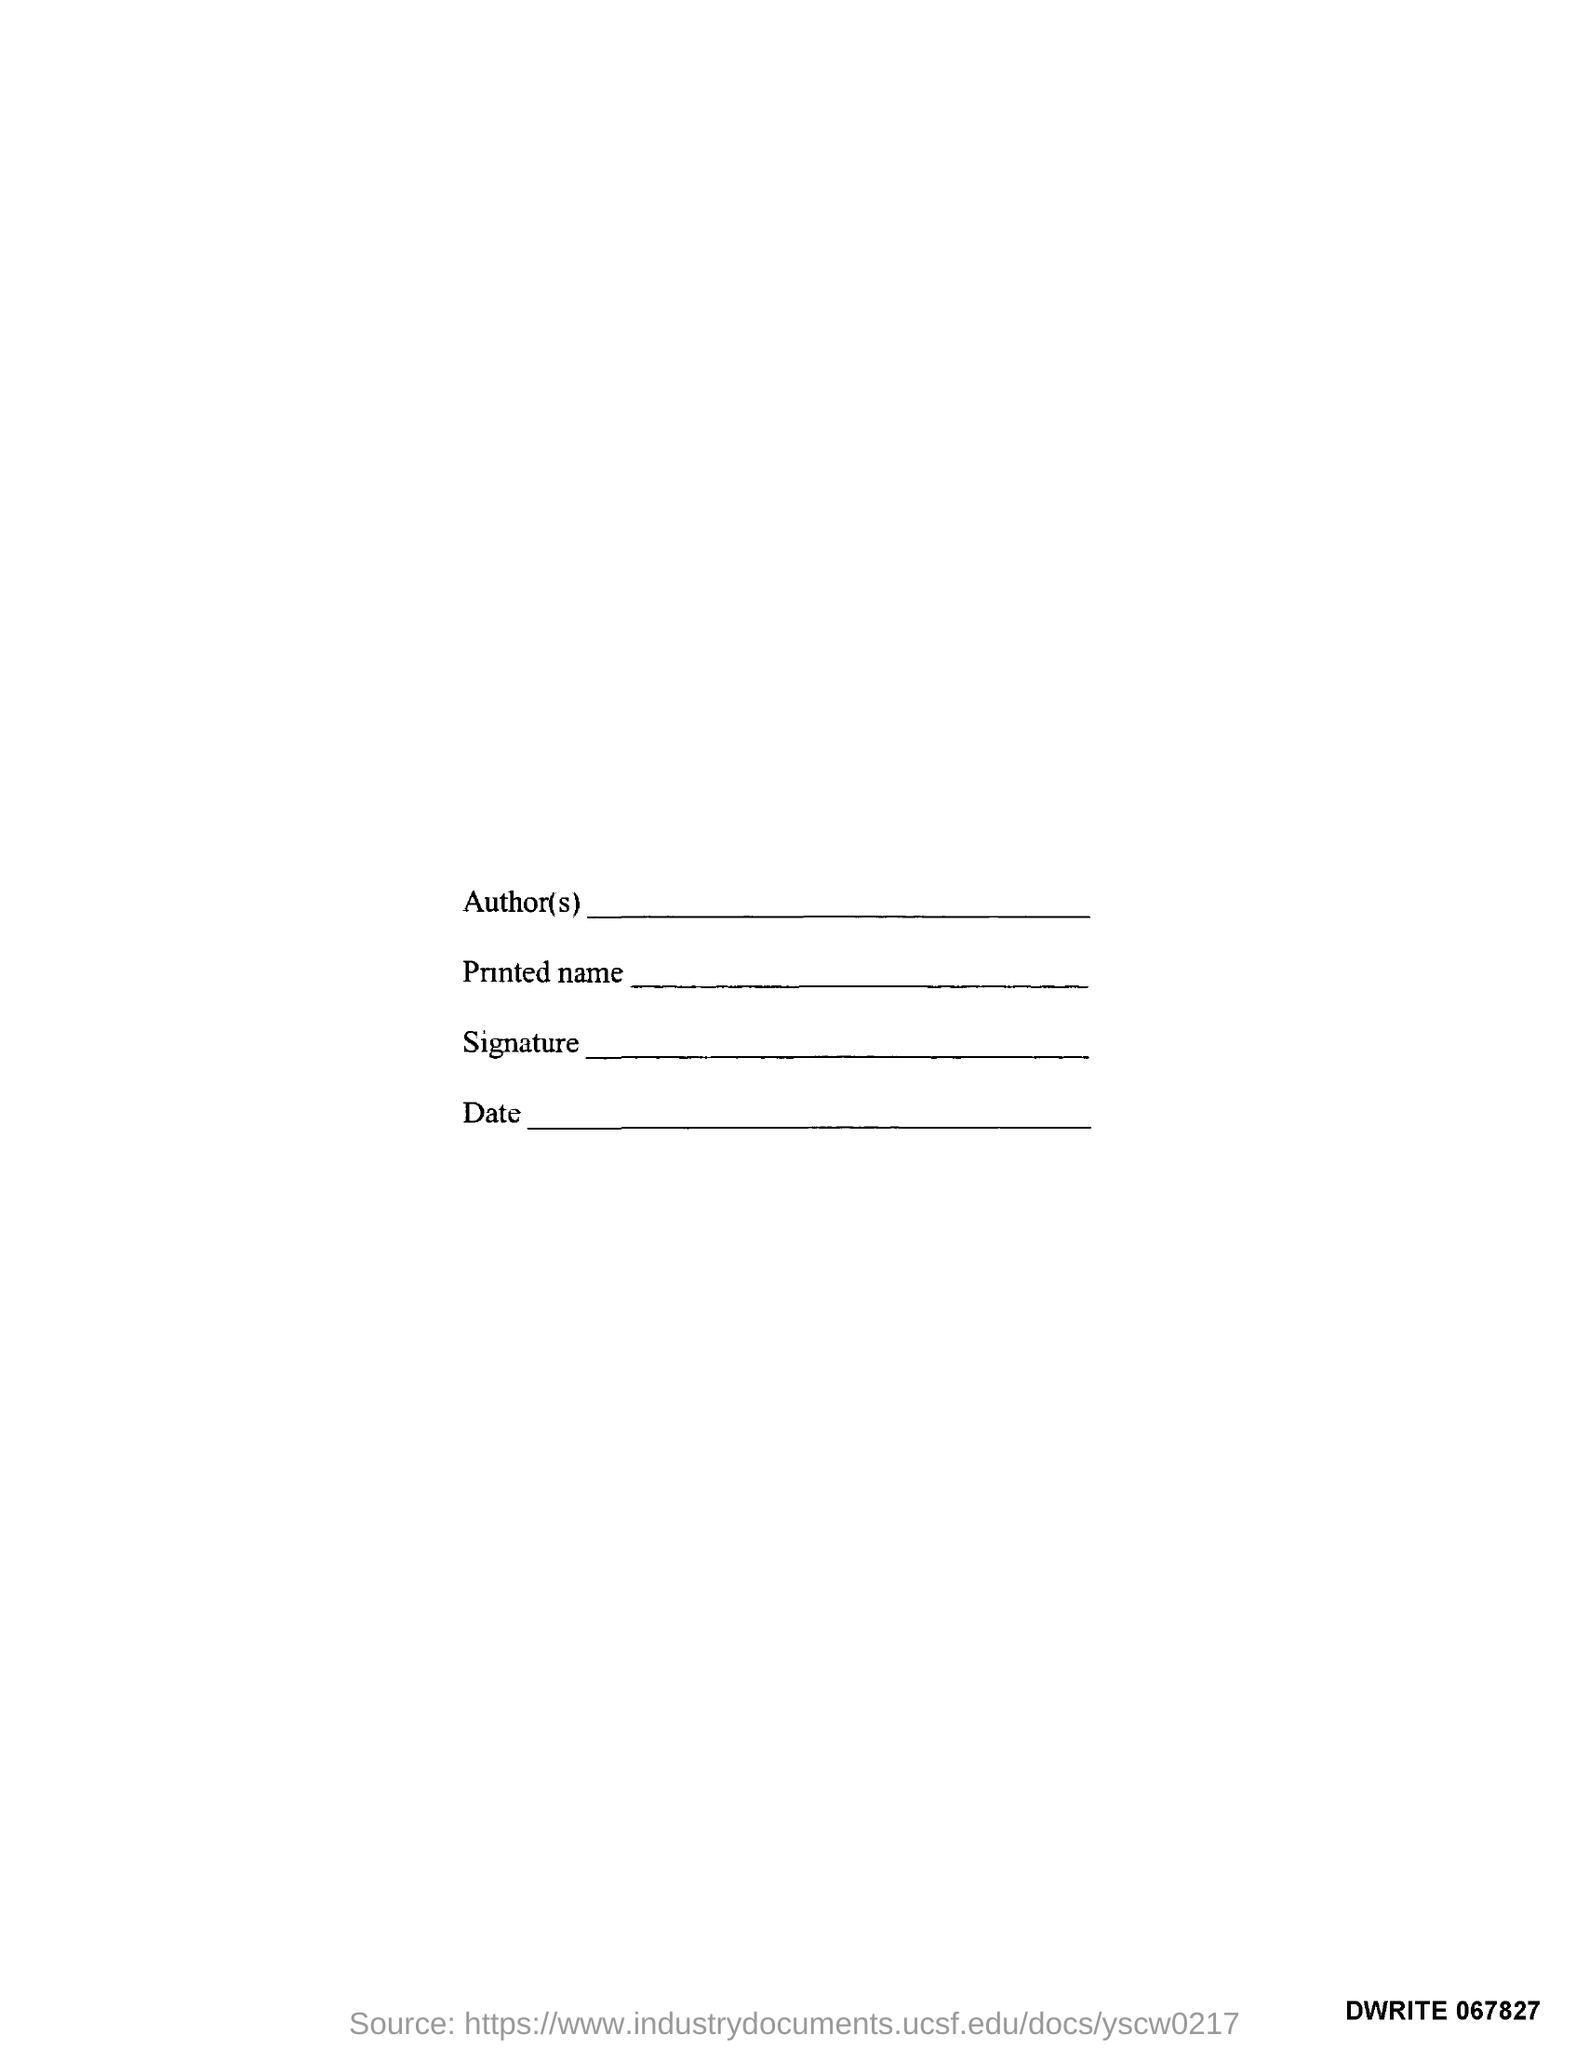Identify some key points in this picture. The fourth text in the document is dated. The first text in the document is "What is the first text in the document? Author(s)..". The third text in the document is "Signature. 